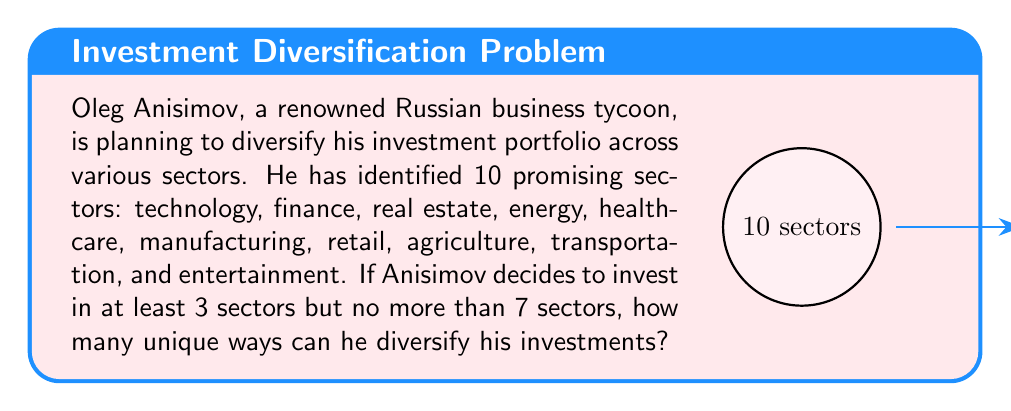Solve this math problem. To solve this problem, we need to use the concept of combinations from combinatorics. Let's break it down step-by-step:

1) We need to find the sum of the number of ways to choose 3, 4, 5, 6, and 7 sectors out of 10.

2) The formula for combinations is:

   $${n \choose k} = \frac{n!}{k!(n-k)!}$$

   where $n$ is the total number of items to choose from, and $k$ is the number of items being chosen.

3) Let's calculate each combination:

   For 3 sectors: $${10 \choose 3} = \frac{10!}{3!(10-3)!} = \frac{10!}{3!7!} = 120$$

   For 4 sectors: $${10 \choose 4} = \frac{10!}{4!(10-4)!} = \frac{10!}{4!6!} = 210$$

   For 5 sectors: $${10 \choose 5} = \frac{10!}{5!(10-5)!} = \frac{10!}{5!5!} = 252$$

   For 6 sectors: $${10 \choose 6} = \frac{10!}{6!(10-6)!} = \frac{10!}{6!4!} = 210$$

   For 7 sectors: $${10 \choose 7} = \frac{10!}{7!(10-7)!} = \frac{10!}{7!3!} = 120$$

4) The total number of ways is the sum of all these combinations:

   $$120 + 210 + 252 + 210 + 120 = 912$$

Therefore, Oleg Anisimov can diversify his investments in 912 unique ways.
Answer: 912 